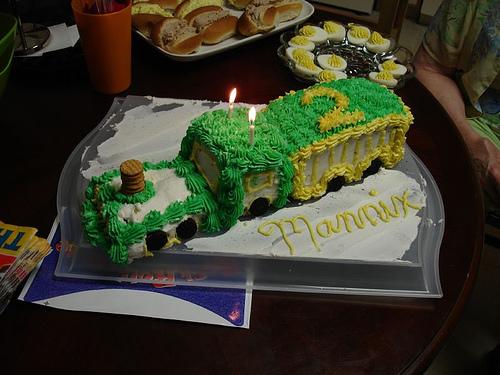What kind of cake is it?
Give a very brief answer. Birthday. What is a sprinkle?
Write a very short answer. Cake. Is this a healthy snack?
Short answer required. No. What is on the clear plate?
Give a very brief answer. Cake. Has the cake been sliced?
Be succinct. No. Which birthday is being celebrated?
Answer briefly. 2nd. What color is the main part of the cake?
Quick response, please. Green. How old do you think the birthday kid is?
Short answer required. 2. What kinds of fruits are in this scene?
Quick response, please. 0. Is there broccoli in this picture?
Answer briefly. No. What does the cake on the far right represent?
Write a very short answer. Train. Is this healthy?
Quick response, please. No. What is mainly featured?
Keep it brief. Cake. Is this a cake competition?
Write a very short answer. No. What color is the frosting?
Give a very brief answer. Green. What kind of cake is that?
Short answer required. Birthday. What is the cake supposed to look like?
Keep it brief. Train. How many desserts are pictured?
Quick response, please. 1. What is in the wagon?
Short answer required. Cake. What is the cake supposed to resemble?
Give a very brief answer. Truck. Are those leaflets at the edge of the foot?
Concise answer only. No. Are the treats on both trays the same kinds?
Write a very short answer. No. What is the food in the clear tray?
Answer briefly. Cake. What object is to the left of the cake?
Be succinct. Napkins. What popular summertime desert features this yellow item?
Answer briefly. Cake. Are these healthy foods?
Write a very short answer. No. What character is this cake supposed to be?
Short answer required. Train. What continent do you think this is?
Concise answer only. North america. How many years old is the recipient of this birthday cake?
Concise answer only. 2. What color was the letters on the cake?
Concise answer only. Yellow. How many candles are there?
Keep it brief. 2. What is the egg dish called?
Quick response, please. Deviled eggs. Is the car edible?
Give a very brief answer. Yes. What else would you like to see on that table that tastes good to you?
Give a very brief answer. Ice cream. Does the cake have candles on it?
Quick response, please. Yes. What is the white stuff under the brown things?
Keep it brief. Frosting. How many candles on the cake?
Keep it brief. 2. Have the cake been cut?
Write a very short answer. No. Is this a sale?
Be succinct. No. What marvel comic character is in this picture?
Be succinct. None. What size is the cake?
Quick response, please. Large. Has this cake been cut yet?
Give a very brief answer. No. 